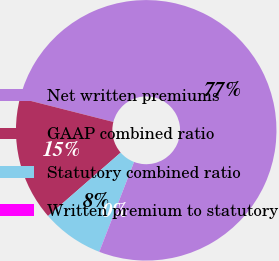Convert chart to OTSL. <chart><loc_0><loc_0><loc_500><loc_500><pie_chart><fcel>Net written premiums<fcel>GAAP combined ratio<fcel>Statutory combined ratio<fcel>Written premium to statutory<nl><fcel>76.88%<fcel>15.39%<fcel>7.71%<fcel>0.02%<nl></chart> 